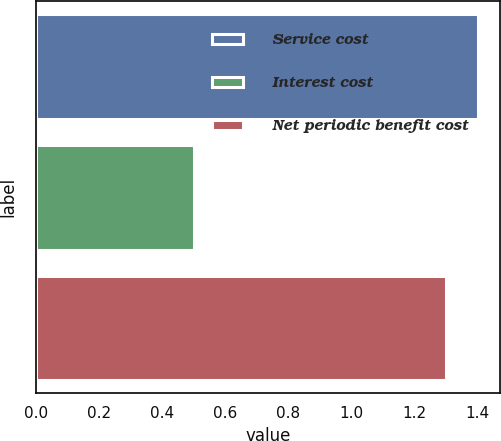<chart> <loc_0><loc_0><loc_500><loc_500><bar_chart><fcel>Service cost<fcel>Interest cost<fcel>Net periodic benefit cost<nl><fcel>1.4<fcel>0.5<fcel>1.3<nl></chart> 